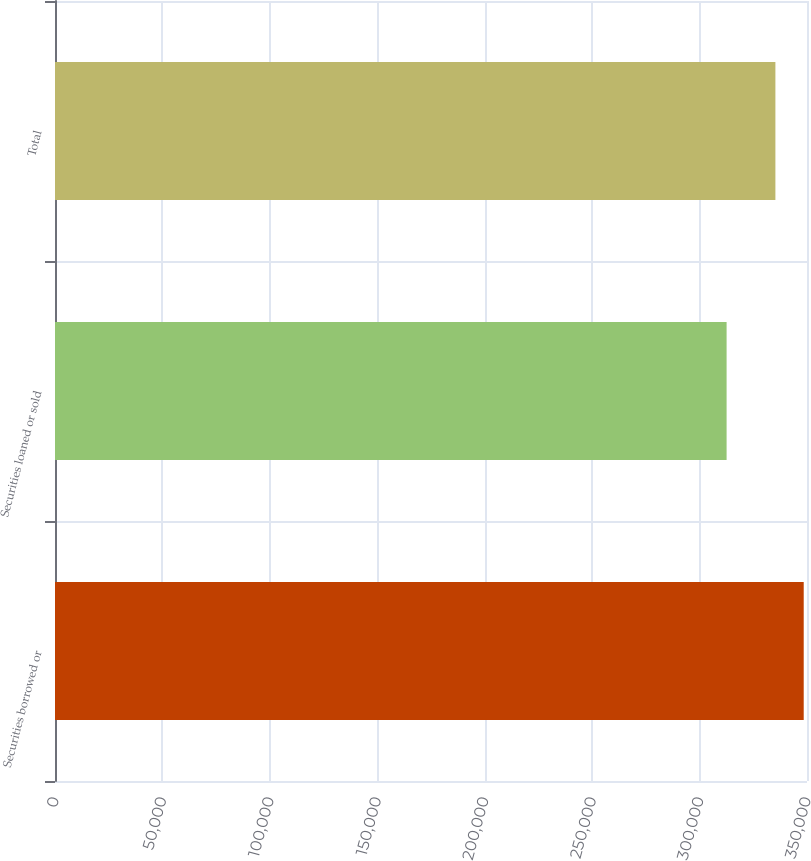Convert chart. <chart><loc_0><loc_0><loc_500><loc_500><bar_chart><fcel>Securities borrowed or<fcel>Securities loaned or sold<fcel>Total<nl><fcel>348472<fcel>312582<fcel>335293<nl></chart> 